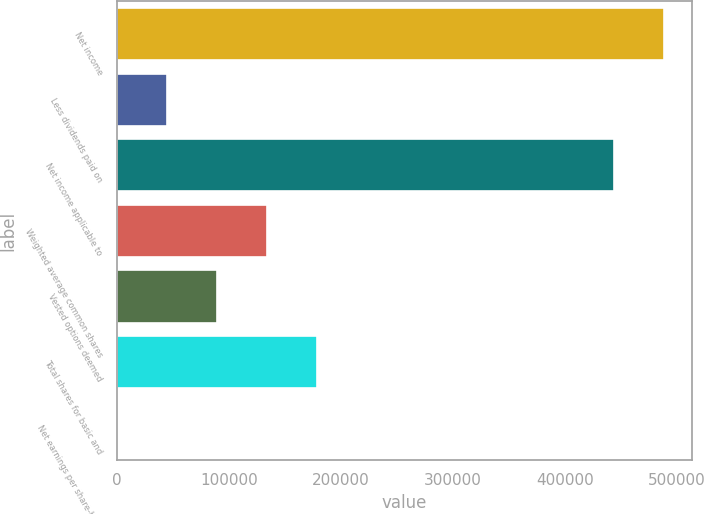Convert chart. <chart><loc_0><loc_0><loc_500><loc_500><bar_chart><fcel>Net income<fcel>Less dividends paid on<fcel>Net income applicable to<fcel>Weighted average common shares<fcel>Vested options deemed<fcel>Total shares for basic and<fcel>Net earnings per share-basic<nl><fcel>488567<fcel>44728.3<fcel>443847<fcel>134169<fcel>89448.7<fcel>178890<fcel>7.84<nl></chart> 